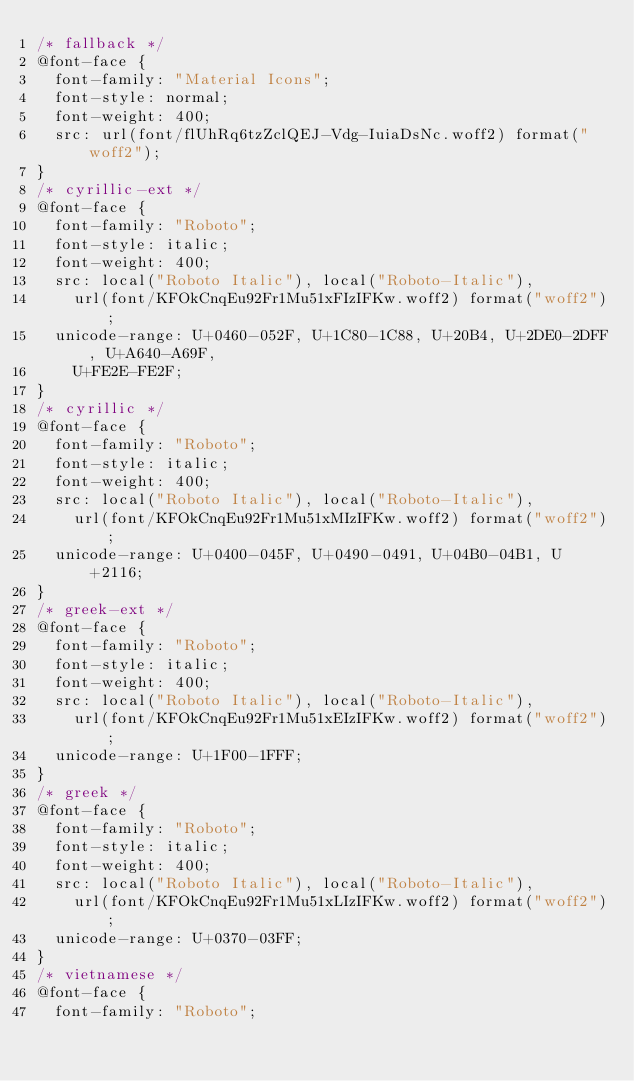Convert code to text. <code><loc_0><loc_0><loc_500><loc_500><_CSS_>/* fallback */
@font-face {
  font-family: "Material Icons";
  font-style: normal;
  font-weight: 400;
  src: url(font/flUhRq6tzZclQEJ-Vdg-IuiaDsNc.woff2) format("woff2");
}
/* cyrillic-ext */
@font-face {
  font-family: "Roboto";
  font-style: italic;
  font-weight: 400;
  src: local("Roboto Italic"), local("Roboto-Italic"),
    url(font/KFOkCnqEu92Fr1Mu51xFIzIFKw.woff2) format("woff2");
  unicode-range: U+0460-052F, U+1C80-1C88, U+20B4, U+2DE0-2DFF, U+A640-A69F,
    U+FE2E-FE2F;
}
/* cyrillic */
@font-face {
  font-family: "Roboto";
  font-style: italic;
  font-weight: 400;
  src: local("Roboto Italic"), local("Roboto-Italic"),
    url(font/KFOkCnqEu92Fr1Mu51xMIzIFKw.woff2) format("woff2");
  unicode-range: U+0400-045F, U+0490-0491, U+04B0-04B1, U+2116;
}
/* greek-ext */
@font-face {
  font-family: "Roboto";
  font-style: italic;
  font-weight: 400;
  src: local("Roboto Italic"), local("Roboto-Italic"),
    url(font/KFOkCnqEu92Fr1Mu51xEIzIFKw.woff2) format("woff2");
  unicode-range: U+1F00-1FFF;
}
/* greek */
@font-face {
  font-family: "Roboto";
  font-style: italic;
  font-weight: 400;
  src: local("Roboto Italic"), local("Roboto-Italic"),
    url(font/KFOkCnqEu92Fr1Mu51xLIzIFKw.woff2) format("woff2");
  unicode-range: U+0370-03FF;
}
/* vietnamese */
@font-face {
  font-family: "Roboto";</code> 